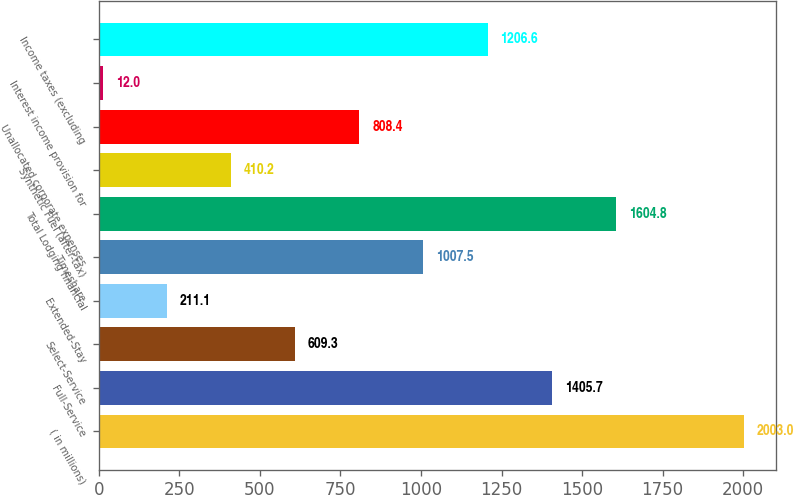<chart> <loc_0><loc_0><loc_500><loc_500><bar_chart><fcel>( in millions)<fcel>Full-Service<fcel>Select-Service<fcel>Extended-Stay<fcel>Timeshare<fcel>Total Lodging financial<fcel>Synthetic Fuel (after-tax)<fcel>Unallocated corporate expenses<fcel>Interest income provision for<fcel>Income taxes (excluding<nl><fcel>2003<fcel>1405.7<fcel>609.3<fcel>211.1<fcel>1007.5<fcel>1604.8<fcel>410.2<fcel>808.4<fcel>12<fcel>1206.6<nl></chart> 